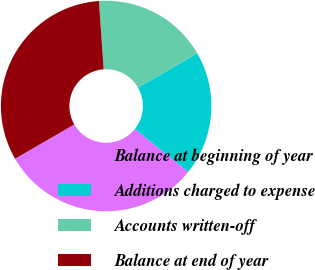<chart> <loc_0><loc_0><loc_500><loc_500><pie_chart><fcel>Balance at beginning of year<fcel>Additions charged to expense<fcel>Accounts written-off<fcel>Balance at end of year<nl><fcel>30.89%<fcel>19.11%<fcel>17.74%<fcel>32.26%<nl></chart> 